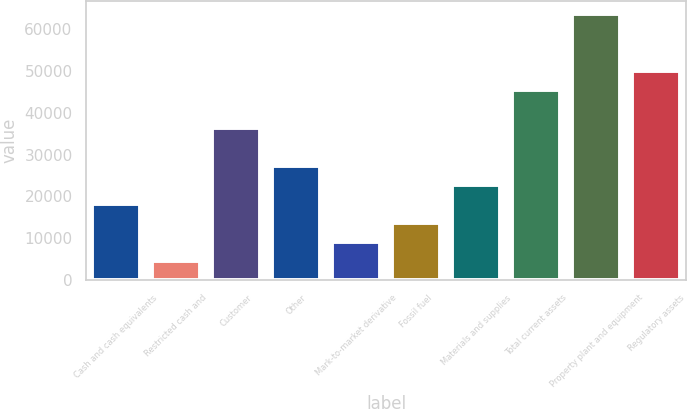<chart> <loc_0><loc_0><loc_500><loc_500><bar_chart><fcel>Cash and cash equivalents<fcel>Restricted cash and<fcel>Customer<fcel>Other<fcel>Mark-to-market derivative<fcel>Fossil fuel<fcel>Materials and supplies<fcel>Total current assets<fcel>Property plant and equipment<fcel>Regulatory assets<nl><fcel>18182.2<fcel>4592.8<fcel>36301.4<fcel>27241.8<fcel>9122.6<fcel>13652.4<fcel>22712<fcel>45361<fcel>63480.2<fcel>49890.8<nl></chart> 